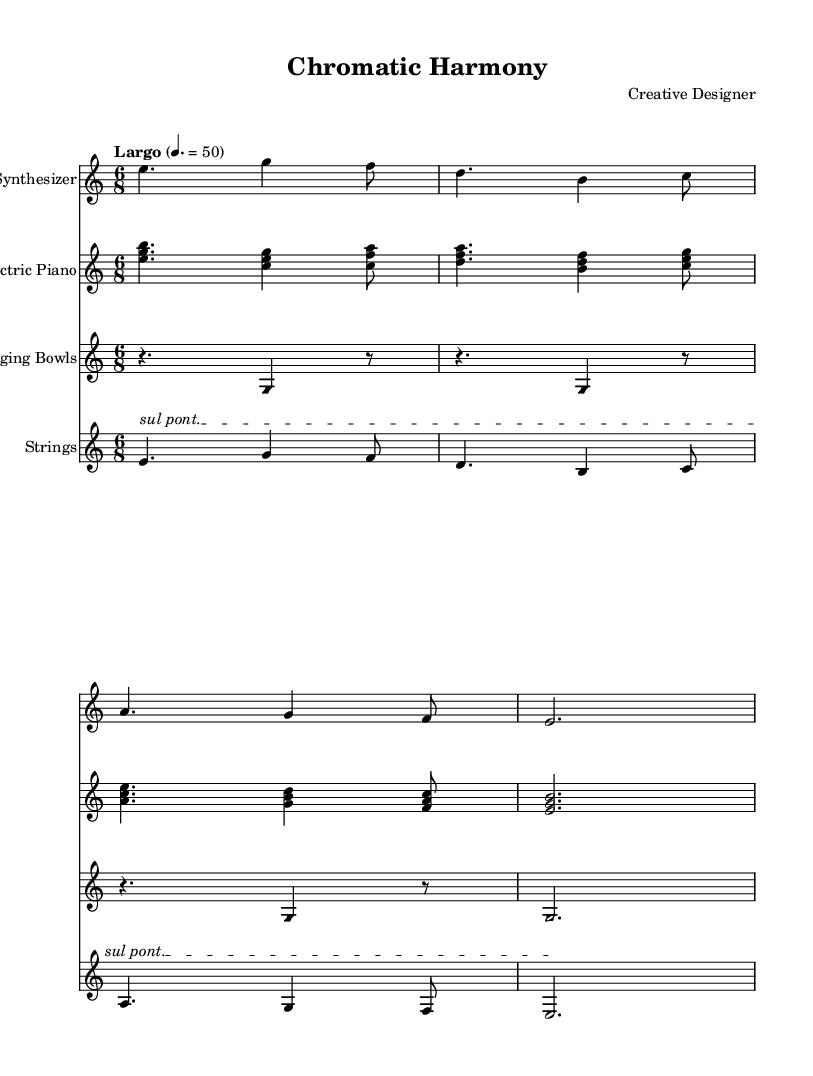What is the time signature of this music? The time signature is displayed at the beginning of the piece, indicating that it is 6/8. This means there are six eighth notes per measure.
Answer: 6/8 What is the tempo marking in the score? The tempo marking is written above the staff as "Largo" with a metronome marking of 50. This indicates a slow tempo.
Answer: Largo, 50 What instruments are included in this composition? By examining the staff labels, the instruments listed are Synthesizer, Electric Piano, Singing Bowls, and Strings. Each instrument has its own staff.
Answer: Synthesizer, Electric Piano, Singing Bowls, Strings How many measures are present in the Synthesizer part? Counting the individual groupings of notes (or rests) within the Synthesizer staff shows there are four measures in total. Each grouping is delineated by the bar lines.
Answer: 4 What note values are predominantly used in the Electric Piano section? In the Electric Piano part, a combination of dotted half notes and quarter notes is utilized, indicating longer and shorter note durations. The presence of eighth notes also suggests a rhythmic flow.
Answer: Dotted half notes and quarter notes Which playing technique is indicated for the Strings ensemble? The score for the Strings indicates "sul pont.", which is a special playing technique directing the player to bow near the bridge of the instrument. This contributes to the unique sound texture.
Answer: sul pont Explain the visual harmony concept in this piece. The use of sustained harmonies and ethereal textures in this ambient piece creates a visually pleasing auditory effect, aligning with color theory principles to evoke specific feelings and atmospheres.
Answer: Sustained harmonies and textures 